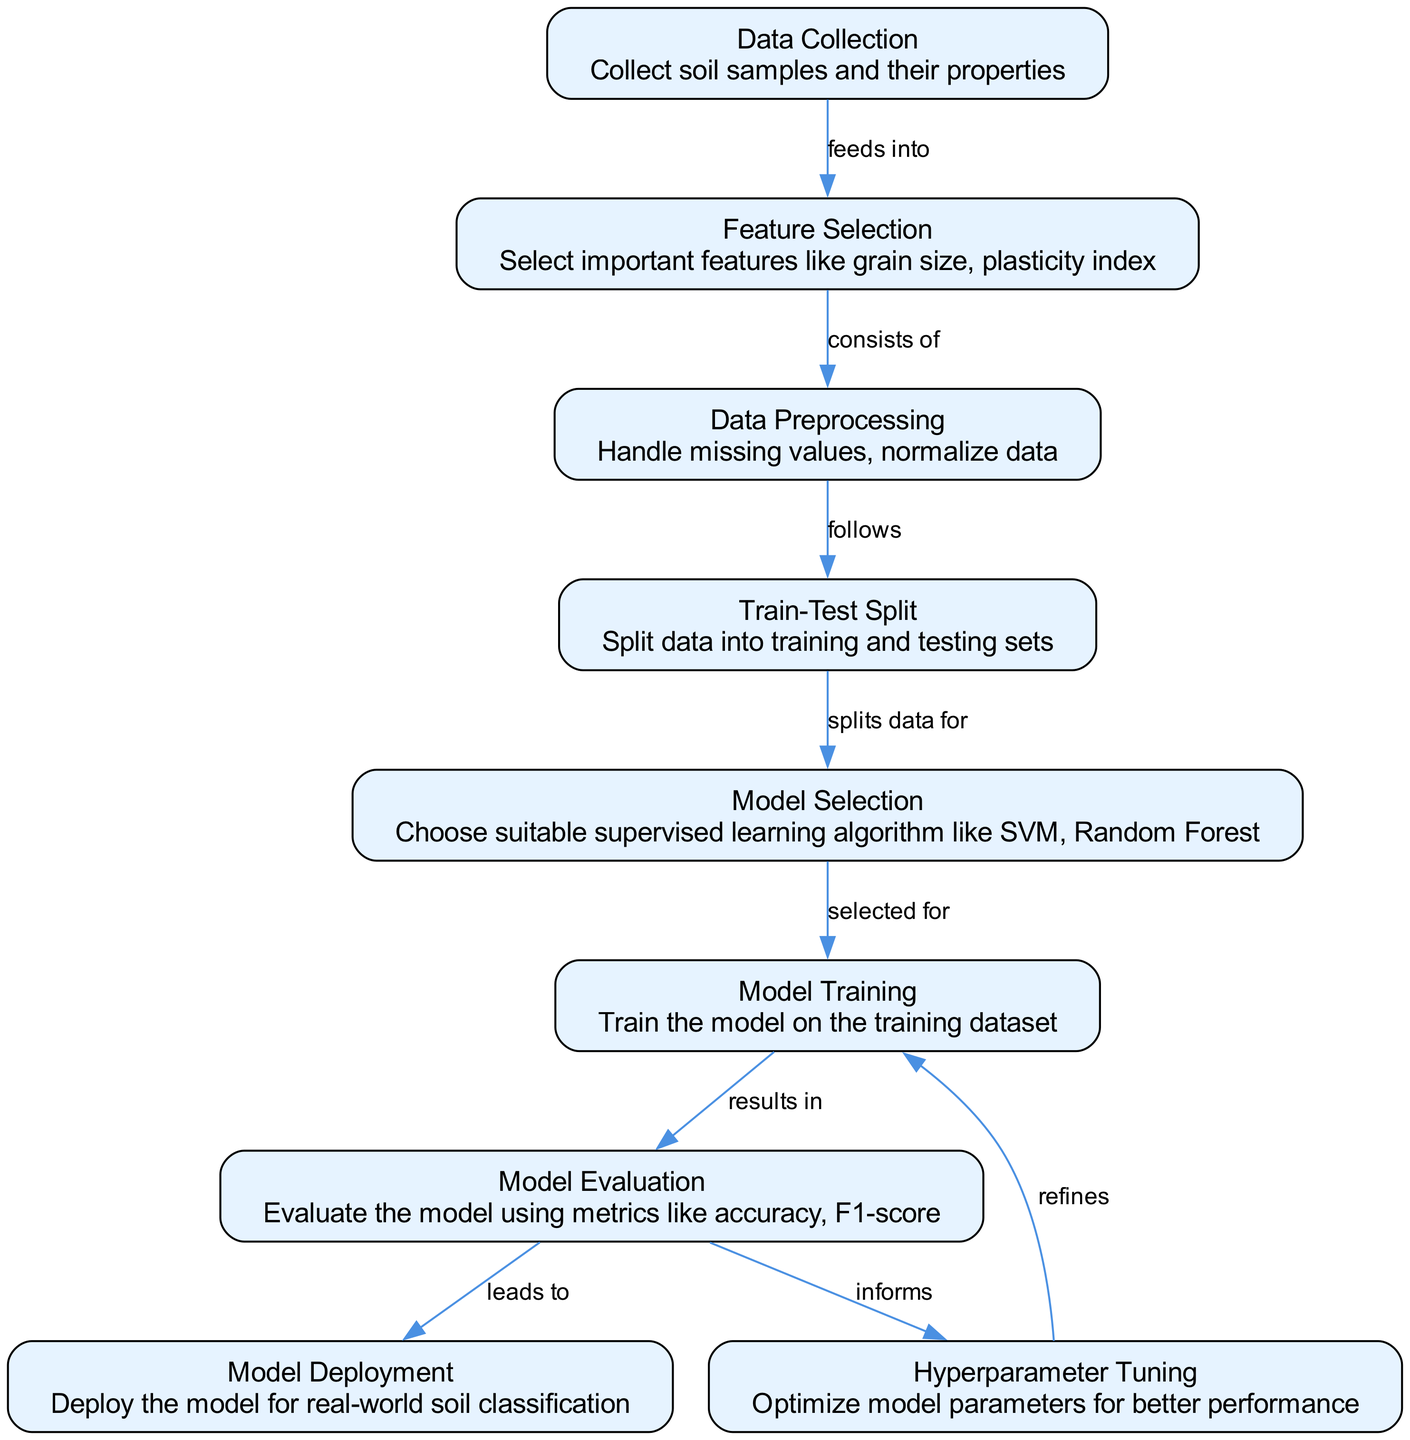What is the first step in the machine learning process depicted in the diagram? The first step in the process is labeled "Data Collection." It is the initial node that begins the workflow for soil type classification using supervised learning.
Answer: Data Collection How many nodes are present in the diagram? Counting all the nodes listed in the diagram, there are a total of nine nodes representing various steps in the machine learning workflow.
Answer: Nine Which node leads to Model Evaluation? In the diagram, the "Model Training" node directly leads to the "Model Evaluation" node, indicating that evaluation occurs after training the model.
Answer: Model Training What type of model algorithms are suggested in the Model Selection step? The "Model Selection" node describes selecting suitable supervised learning algorithms, specifically mentioning Support Vector Machine (SVM) and Random Forest as examples.
Answer: SVM, Random Forest What action follows the "Data Preprocessing" node? After "Data Preprocessing," the next action in the workflow is represented by the "Train-Test Split" node, indicating that data is split into training and testing sets following preprocessing.
Answer: Train-Test Split What is refined during the Hyperparameter Tuning step? The "Model Training" node is refined during the Hyperparameter Tuning step, as this involves optimizing model parameters for better performance.
Answer: Model Training Which step in the diagram informs the Hyperparameter Tuning process? The "Model Evaluation" step informs the Hyperparameter Tuning process by providing feedback on model performance, which guides the optimization of parameters.
Answer: Model Evaluation What is the final output of the machine learning process depicted in the diagram? The final output of the process is "Model Deployment," which indicates that the trained model is ready to be deployed for real-world soil classification tasks.
Answer: Model Deployment 